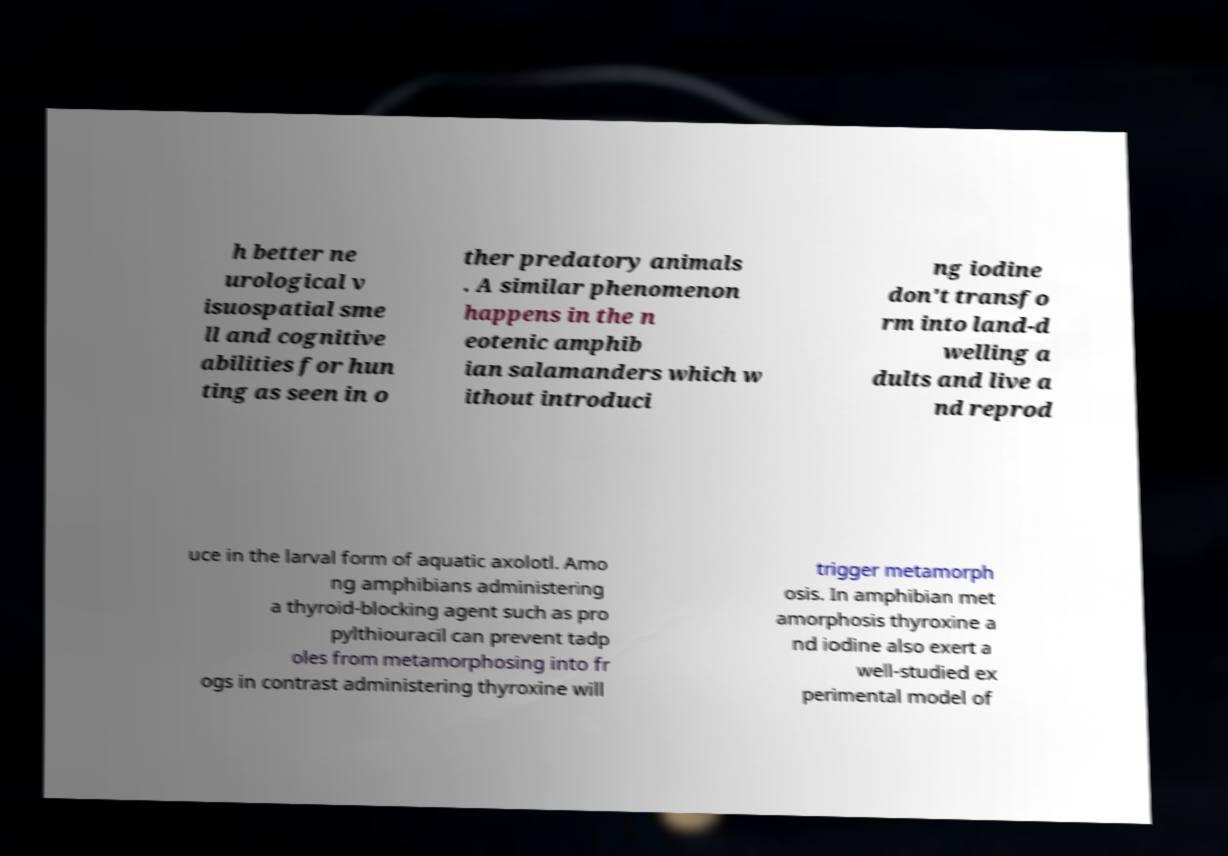Please identify and transcribe the text found in this image. h better ne urological v isuospatial sme ll and cognitive abilities for hun ting as seen in o ther predatory animals . A similar phenomenon happens in the n eotenic amphib ian salamanders which w ithout introduci ng iodine don't transfo rm into land-d welling a dults and live a nd reprod uce in the larval form of aquatic axolotl. Amo ng amphibians administering a thyroid-blocking agent such as pro pylthiouracil can prevent tadp oles from metamorphosing into fr ogs in contrast administering thyroxine will trigger metamorph osis. In amphibian met amorphosis thyroxine a nd iodine also exert a well-studied ex perimental model of 